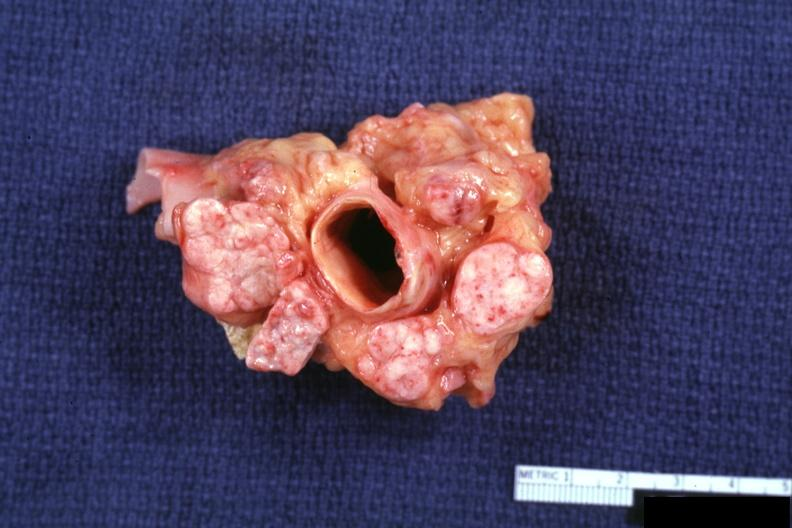s metastatic carcinoma prostate present?
Answer the question using a single word or phrase. Yes 